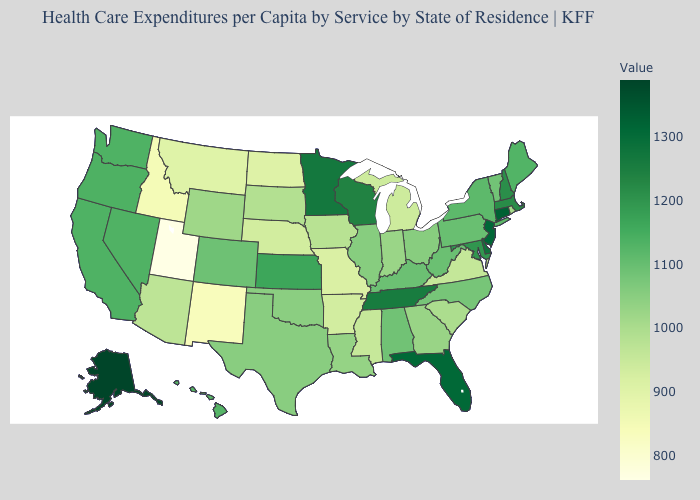Does Utah have the lowest value in the West?
Write a very short answer. Yes. Does Florida have the highest value in the South?
Be succinct. Yes. Among the states that border Mississippi , does Tennessee have the highest value?
Answer briefly. Yes. 